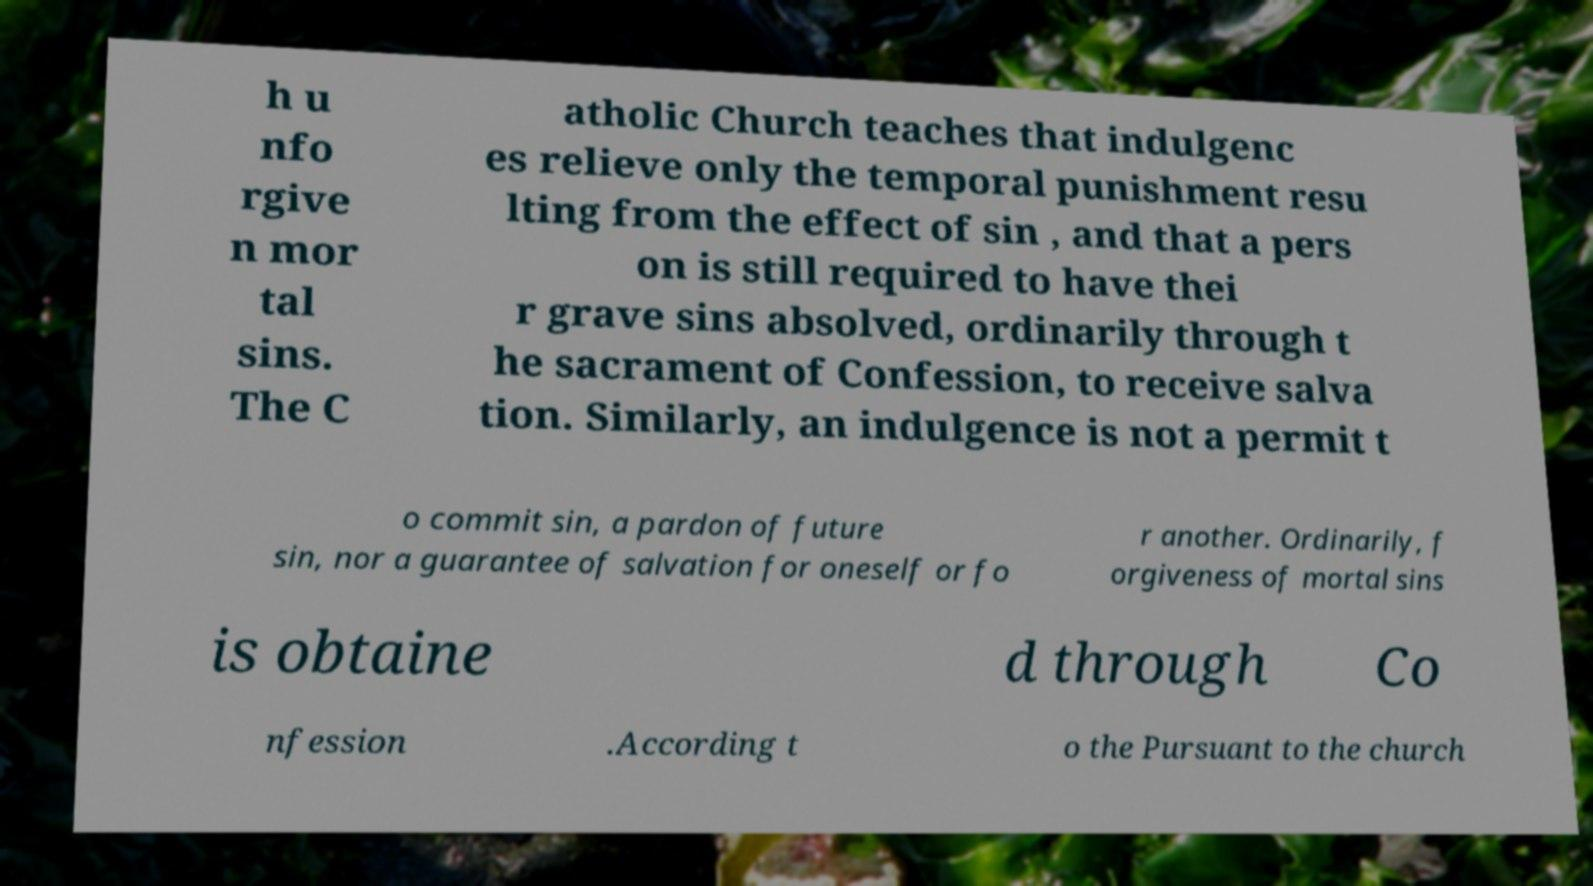For documentation purposes, I need the text within this image transcribed. Could you provide that? h u nfo rgive n mor tal sins. The C atholic Church teaches that indulgenc es relieve only the temporal punishment resu lting from the effect of sin , and that a pers on is still required to have thei r grave sins absolved, ordinarily through t he sacrament of Confession, to receive salva tion. Similarly, an indulgence is not a permit t o commit sin, a pardon of future sin, nor a guarantee of salvation for oneself or fo r another. Ordinarily, f orgiveness of mortal sins is obtaine d through Co nfession .According t o the Pursuant to the church 